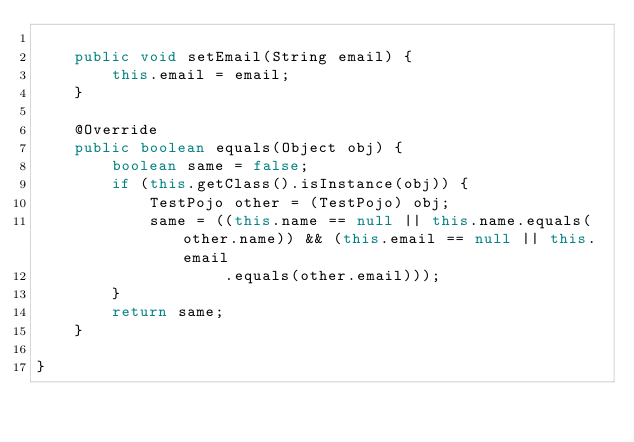<code> <loc_0><loc_0><loc_500><loc_500><_Java_>
	public void setEmail(String email) {
		this.email = email;
	}

	@Override
	public boolean equals(Object obj) {
		boolean same = false;
		if (this.getClass().isInstance(obj)) {
			TestPojo other = (TestPojo) obj;
			same = ((this.name == null || this.name.equals(other.name)) && (this.email == null || this.email
					.equals(other.email)));
		}
		return same;
	}

}
</code> 